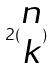Convert formula to latex. <formula><loc_0><loc_0><loc_500><loc_500>2 ( \begin{matrix} n \\ k \end{matrix} )</formula> 